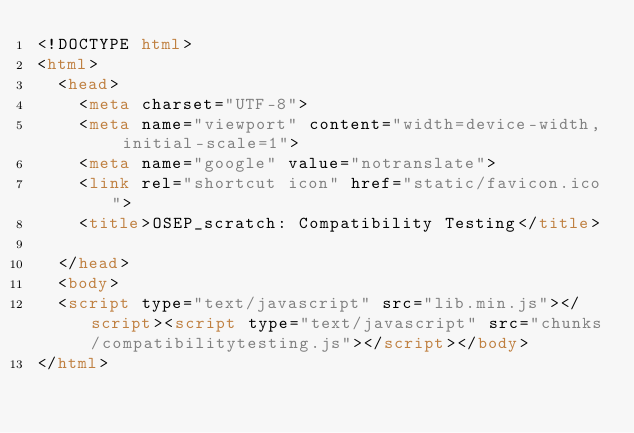<code> <loc_0><loc_0><loc_500><loc_500><_HTML_><!DOCTYPE html>
<html>
  <head>
    <meta charset="UTF-8">
    <meta name="viewport" content="width=device-width, initial-scale=1">
    <meta name="google" value="notranslate">
    <link rel="shortcut icon" href="static/favicon.ico">
    <title>OSEP_scratch: Compatibility Testing</title>
    
  </head>
  <body>
  <script type="text/javascript" src="lib.min.js"></script><script type="text/javascript" src="chunks/compatibilitytesting.js"></script></body>
</html>
</code> 